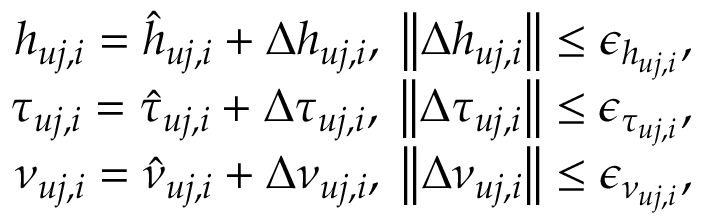<formula> <loc_0><loc_0><loc_500><loc_500>\begin{array} { r } { { h _ { u j , i } } = { { \hat { h } } _ { u j , i } } + \Delta { h _ { u j , i } } , \, \left \| { \Delta { h _ { u j , i } } } \right \| \leq { \epsilon _ { { h _ { u j , i } } } } , } \\ { { \tau _ { u j , i } } = { { \hat { \tau } } _ { u j , i } } + \Delta { \tau _ { u j , i } } , \, \left \| { \Delta { \tau _ { u j , i } } } \right \| \leq { \epsilon _ { { \tau _ { u j , i } } } } , } \\ { { \nu _ { u j , i } } = { { \hat { \nu } } _ { u j , i } } + \Delta { \nu _ { u j , i } } , \, \left \| { \Delta { \nu _ { u j , i } } } \right \| \leq { \epsilon _ { { \nu _ { u j , i } } } } , } \end{array}</formula> 